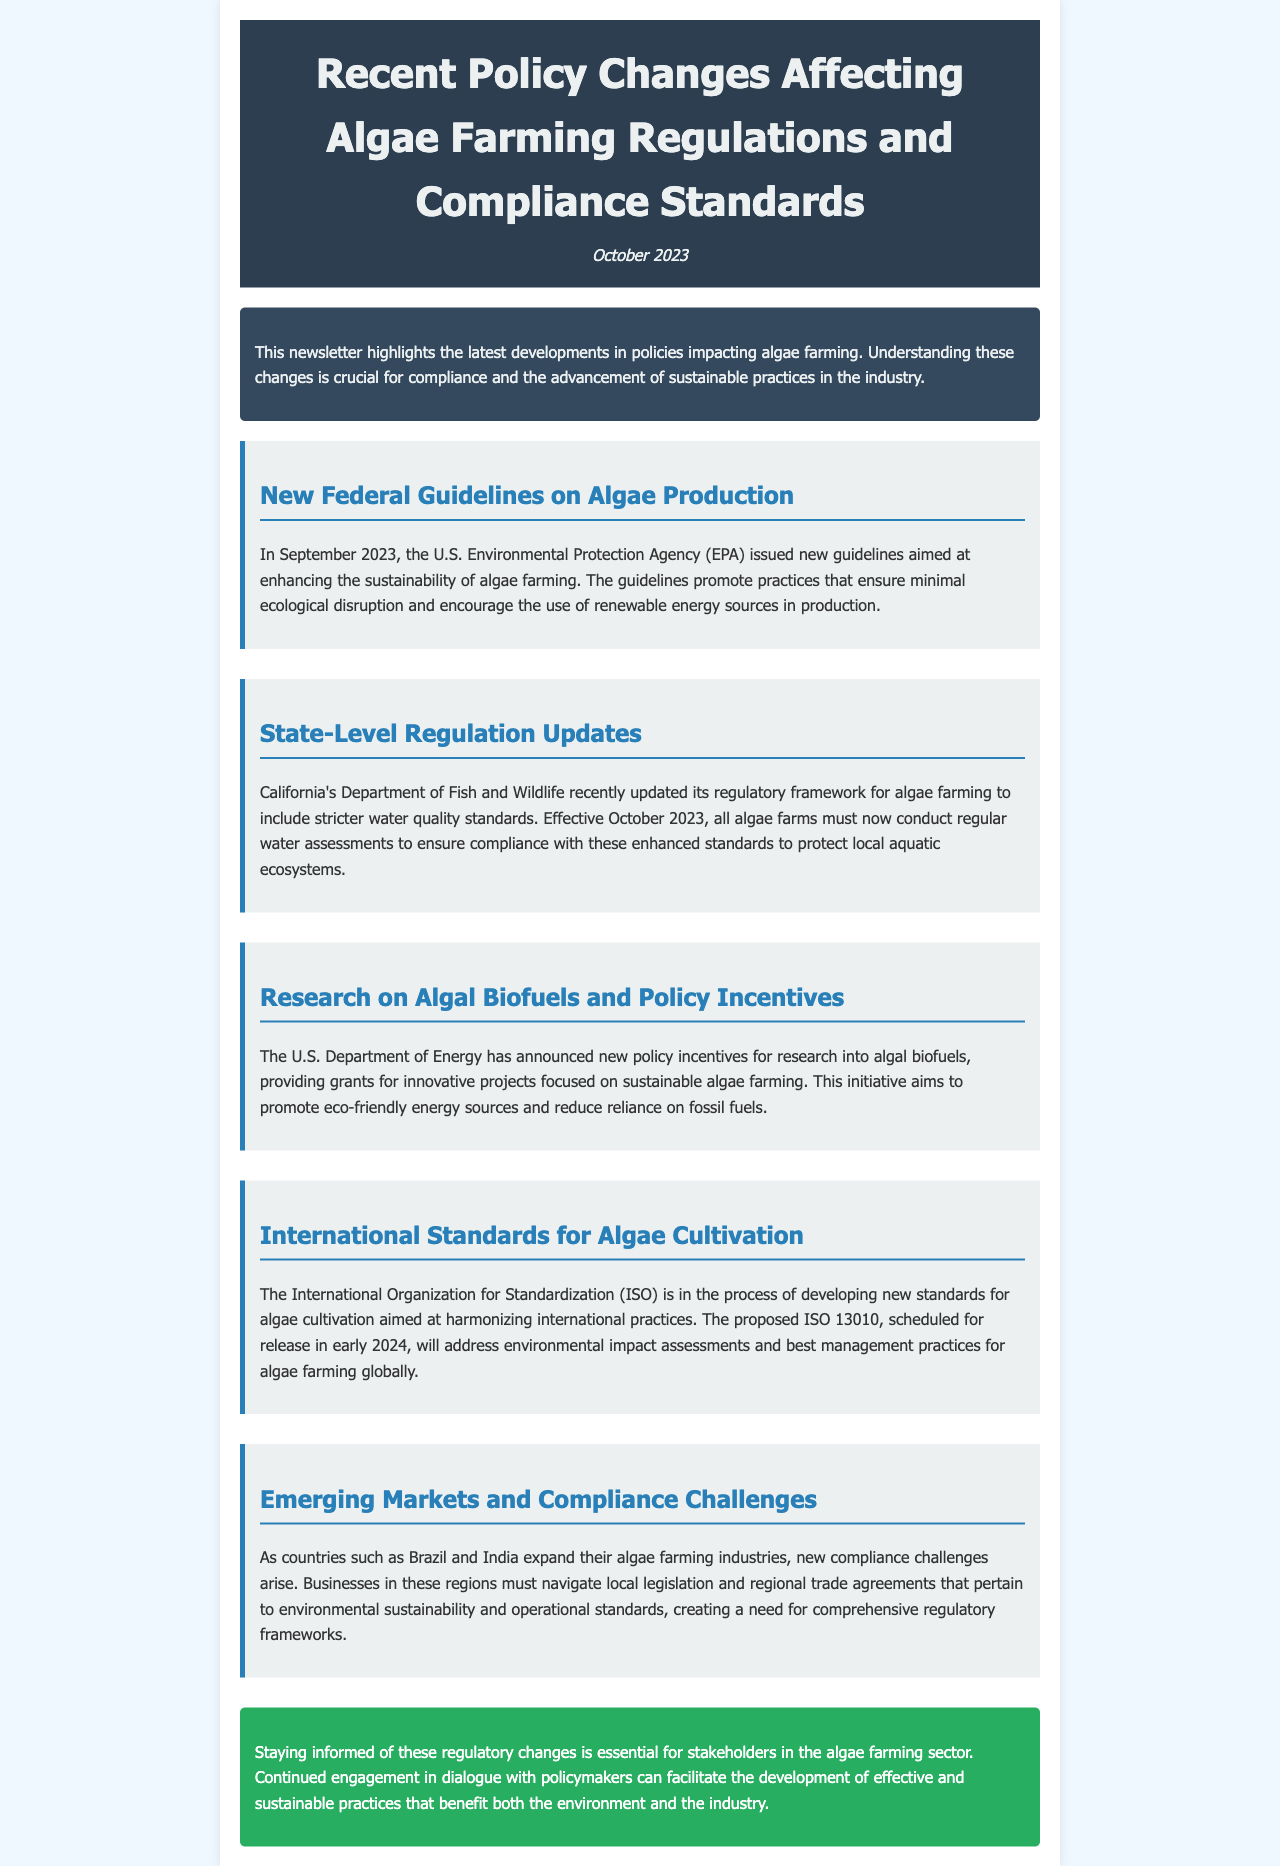What are the new federal guidelines aimed at enhancing? The new federal guidelines issued by the EPA aim at enhancing the sustainability of algae farming.
Answer: sustainability When did California's Department of Fish and Wildlife update its regulatory framework? The update to California's regulatory framework for algae farming occurred in October 2023.
Answer: October 2023 What type of standards are included in California's updated regulations? The updated regulations include stricter water quality standards.
Answer: water quality standards What is the purpose of the U.S. Department of Energy's new policy incentives? The new policy incentives aim to promote research into algal biofuels that focus on sustainable algae farming.
Answer: research into algal biofuels What is the proposed ISO 13010 scheduled to address? The proposed ISO 13010 is scheduled to address environmental impact assessments and best management practices for algae farming.
Answer: environmental impact assessments and best management practices Which countries are mentioned as expanding their algae farming industries? Brazil and India are mentioned as countries expanding their algae farming industries.
Answer: Brazil and India What is essential for stakeholders in the algae farming sector according to the conclusion? Staying informed of regulatory changes is essential for stakeholders in the algae farming sector.
Answer: Staying informed of regulatory changes What does the document primarily focus on? The document primarily focuses on recent policy changes affecting algae farming regulations and compliance standards.
Answer: recent policy changes affecting algae farming regulations and compliance standards 